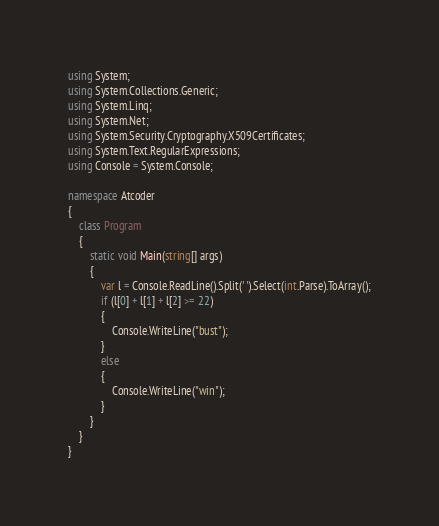<code> <loc_0><loc_0><loc_500><loc_500><_C#_>using System;
using System.Collections.Generic;
using System.Linq;
using System.Net;
using System.Security.Cryptography.X509Certificates;
using System.Text.RegularExpressions;
using Console = System.Console;

namespace Atcoder
{
    class Program
    {
        static void Main(string[] args)
        {
            var l = Console.ReadLine().Split(' ').Select(int.Parse).ToArray();
            if (l[0] + l[1] + l[2] >= 22)
            {
                Console.WriteLine("bust");
            }
            else
            {
                Console.WriteLine("win");
            }
        }
    }
}</code> 